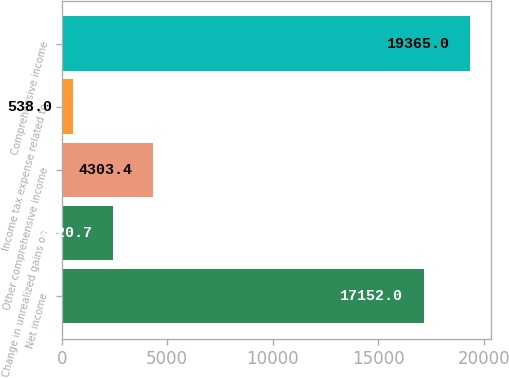Convert chart. <chart><loc_0><loc_0><loc_500><loc_500><bar_chart><fcel>Net income<fcel>Change in unrealized gains on<fcel>Other comprehensive income<fcel>Income tax expense related to<fcel>Comprehensive income<nl><fcel>17152<fcel>2420.7<fcel>4303.4<fcel>538<fcel>19365<nl></chart> 